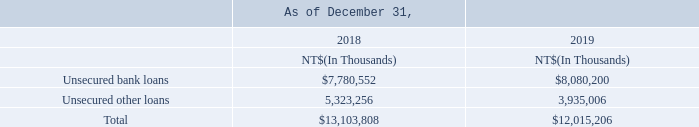The Company’s unused short-term lines of credit amounted to NT$77,658 million and NT$64,169 million as of December 31, 2018 and 2019, respectively.
(10) Short-Term Loans
What were the company's unsecured bank loans in 2019? $7,780,552. How much was Company’s unused short-term lines of credit as of December 31, 2018? Nt$77,658 million. How much was Company’s unused short-term lines of credit as of December 31, 2019? Nt$64,169 million. What is the total Unsecured bank loans?
Answer scale should be: million. 7,780,552+8,080,200
Answer: 15860752. What is the total Unsecured other loans?
Answer scale should be: million. 5,323,256+3,935,006
Answer: 9258262. What is the average Unsecured other loans?
Answer scale should be: million. (5,323,256+3,935,006) / 2
Answer: 4629131. 